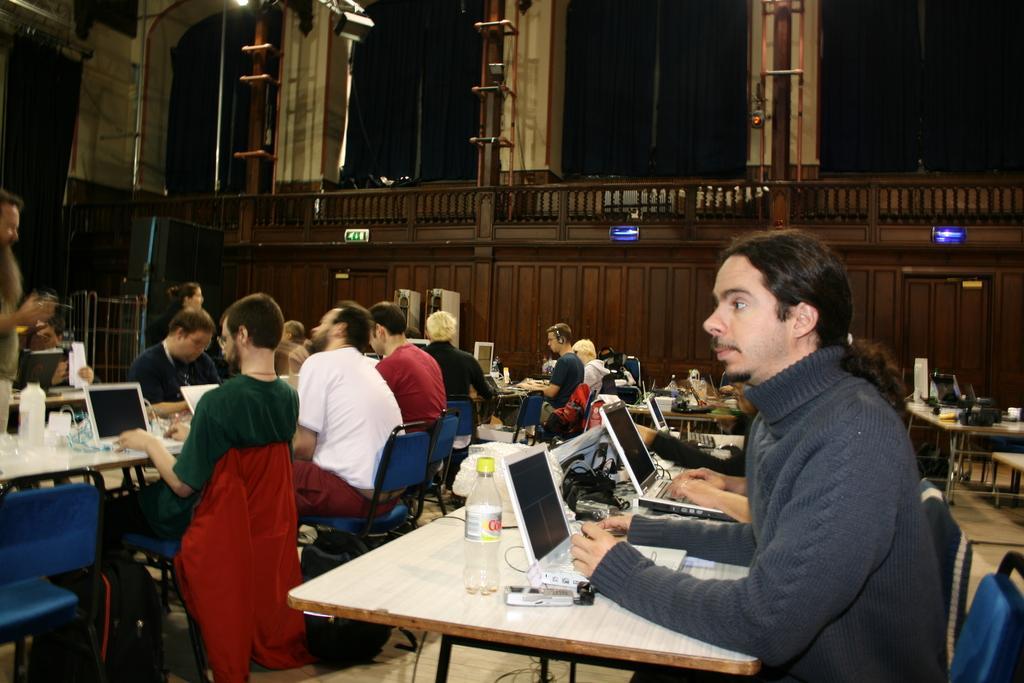Please provide a concise description of this image. In this picture we can see a group of people are sitting on the chair, and in front here is the table and laptop and some objects on it, and here is the pillar. 